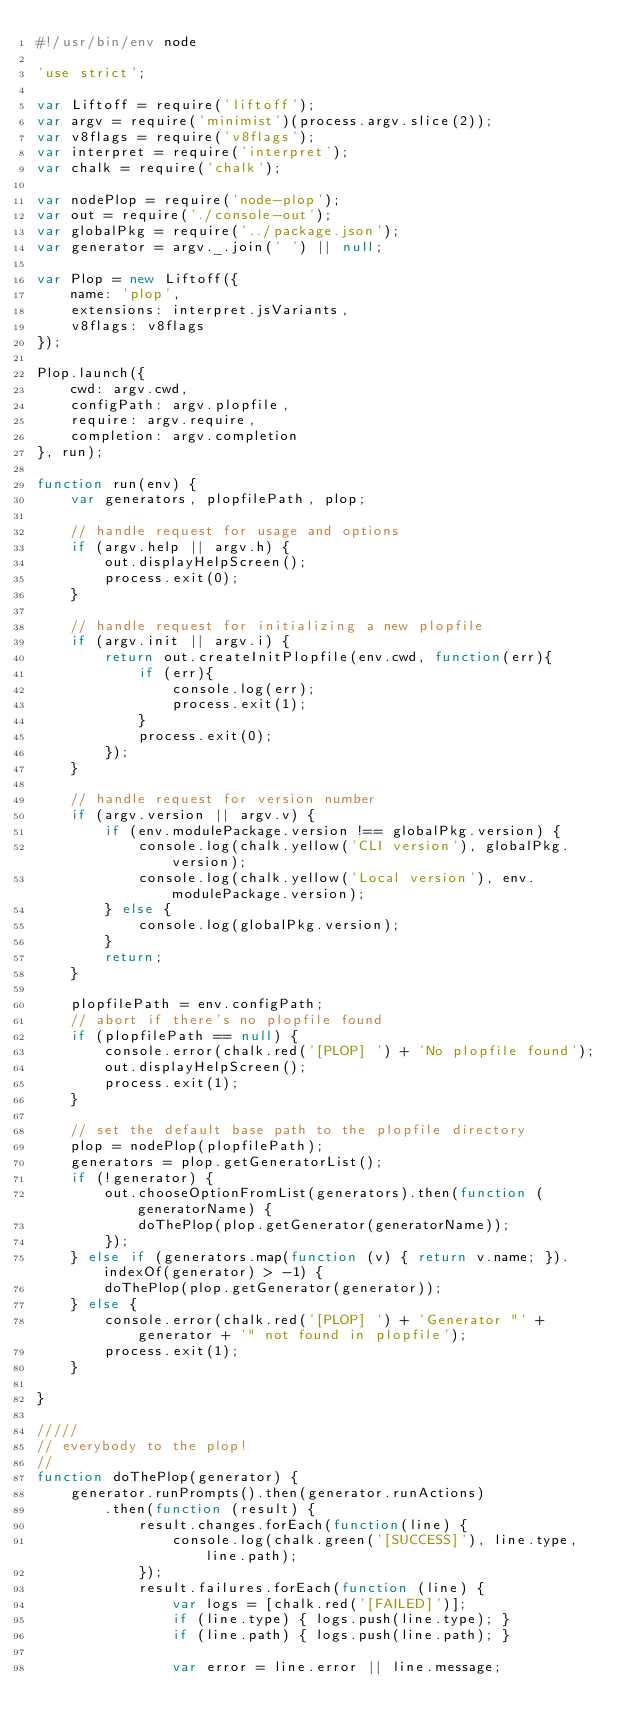<code> <loc_0><loc_0><loc_500><loc_500><_JavaScript_>#!/usr/bin/env node

'use strict';

var Liftoff = require('liftoff');
var argv = require('minimist')(process.argv.slice(2));
var v8flags = require('v8flags');
var interpret = require('interpret');
var chalk = require('chalk');

var nodePlop = require('node-plop');
var out = require('./console-out');
var globalPkg = require('../package.json');
var generator = argv._.join(' ') || null;

var Plop = new Liftoff({
	name: 'plop',
	extensions: interpret.jsVariants,
	v8flags: v8flags
});

Plop.launch({
	cwd: argv.cwd,
	configPath: argv.plopfile,
	require: argv.require,
	completion: argv.completion
}, run);

function run(env) {
	var generators, plopfilePath, plop;

	// handle request for usage and options
	if (argv.help || argv.h) {
		out.displayHelpScreen();
		process.exit(0);
	}

	// handle request for initializing a new plopfile
	if (argv.init || argv.i) {
		return out.createInitPlopfile(env.cwd, function(err){
			if (err){
				console.log(err);
				process.exit(1);
			}
			process.exit(0);
		});
	}

	// handle request for version number
	if (argv.version || argv.v) {
		if (env.modulePackage.version !== globalPkg.version) {
			console.log(chalk.yellow('CLI version'), globalPkg.version);
			console.log(chalk.yellow('Local version'), env.modulePackage.version);
		} else {
			console.log(globalPkg.version);
		}
		return;
	}

	plopfilePath = env.configPath;
	// abort if there's no plopfile found
	if (plopfilePath == null) {
		console.error(chalk.red('[PLOP] ') + 'No plopfile found');
		out.displayHelpScreen();
		process.exit(1);
	}

	// set the default base path to the plopfile directory
	plop = nodePlop(plopfilePath);
	generators = plop.getGeneratorList();
	if (!generator) {
		out.chooseOptionFromList(generators).then(function (generatorName) {
			doThePlop(plop.getGenerator(generatorName));
		});
	} else if (generators.map(function (v) { return v.name; }).indexOf(generator) > -1) {
		doThePlop(plop.getGenerator(generator));
	} else {
		console.error(chalk.red('[PLOP] ') + 'Generator "' + generator + '" not found in plopfile');
		process.exit(1);
	}

}

/////
// everybody to the plop!
//
function doThePlop(generator) {
	generator.runPrompts().then(generator.runActions)
		.then(function (result) {
			result.changes.forEach(function(line) {
				console.log(chalk.green('[SUCCESS]'), line.type, line.path);
			});
			result.failures.forEach(function (line) {
				var logs = [chalk.red('[FAILED]')];
				if (line.type) { logs.push(line.type); }
				if (line.path) { logs.push(line.path); }

				var error = line.error || line.message;</code> 